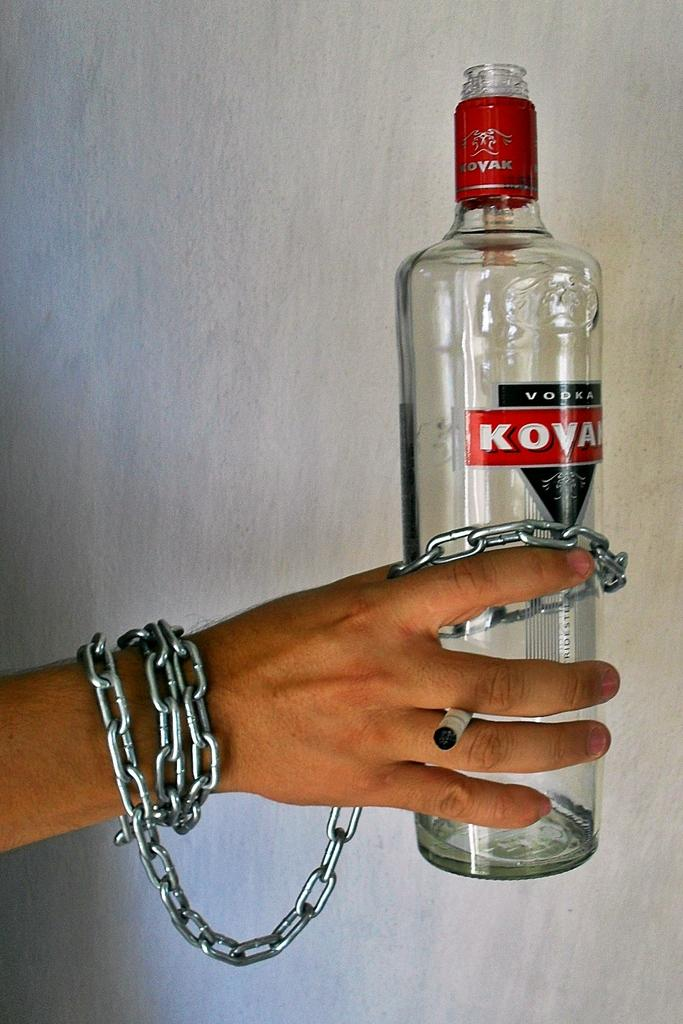<image>
Relay a brief, clear account of the picture shown. A person's right is chained to a bottle of Kovak vodka.. 